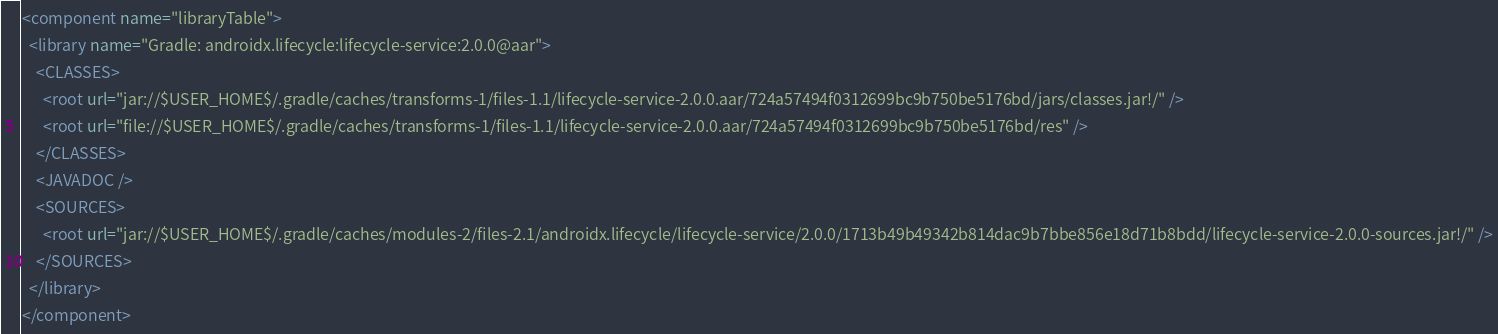<code> <loc_0><loc_0><loc_500><loc_500><_XML_><component name="libraryTable">
  <library name="Gradle: androidx.lifecycle:lifecycle-service:2.0.0@aar">
    <CLASSES>
      <root url="jar://$USER_HOME$/.gradle/caches/transforms-1/files-1.1/lifecycle-service-2.0.0.aar/724a57494f0312699bc9b750be5176bd/jars/classes.jar!/" />
      <root url="file://$USER_HOME$/.gradle/caches/transforms-1/files-1.1/lifecycle-service-2.0.0.aar/724a57494f0312699bc9b750be5176bd/res" />
    </CLASSES>
    <JAVADOC />
    <SOURCES>
      <root url="jar://$USER_HOME$/.gradle/caches/modules-2/files-2.1/androidx.lifecycle/lifecycle-service/2.0.0/1713b49b49342b814dac9b7bbe856e18d71b8bdd/lifecycle-service-2.0.0-sources.jar!/" />
    </SOURCES>
  </library>
</component></code> 